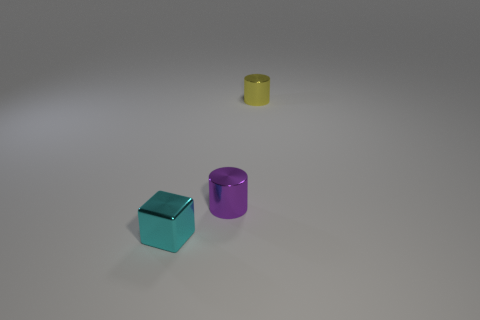Do the small yellow metallic object and the purple thing to the left of the tiny yellow shiny cylinder have the same shape?
Your answer should be very brief. Yes. There is a tiny metal thing that is behind the cylinder that is on the left side of the cylinder behind the purple thing; what is its shape?
Give a very brief answer. Cylinder. What is the color of the small metallic object that is in front of the yellow shiny object and right of the small block?
Ensure brevity in your answer.  Purple. What number of other things are there of the same shape as the small cyan object?
Ensure brevity in your answer.  0. There is a metallic object that is behind the tiny purple shiny thing; is its size the same as the metal cylinder that is to the left of the yellow object?
Make the answer very short. Yes. What material is the small object that is left of the metal cylinder in front of the shiny cylinder that is to the right of the tiny purple metallic object?
Provide a short and direct response. Metal. Do the small purple object and the yellow metallic thing have the same shape?
Offer a terse response. Yes. There is another small object that is the same shape as the yellow metallic thing; what is its material?
Provide a short and direct response. Metal. How many yellow things are tiny objects or cubes?
Give a very brief answer. 1. How many tiny yellow things are behind the metallic cylinder that is to the left of the tiny yellow shiny cylinder?
Your answer should be compact. 1. 